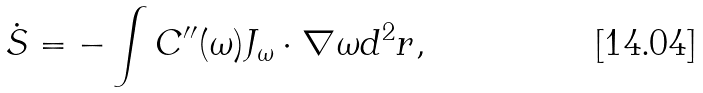<formula> <loc_0><loc_0><loc_500><loc_500>\dot { S } = - \int C ^ { \prime \prime } ( \omega ) { J } _ { \omega } \cdot \nabla \omega d ^ { 2 } { r } ,</formula> 